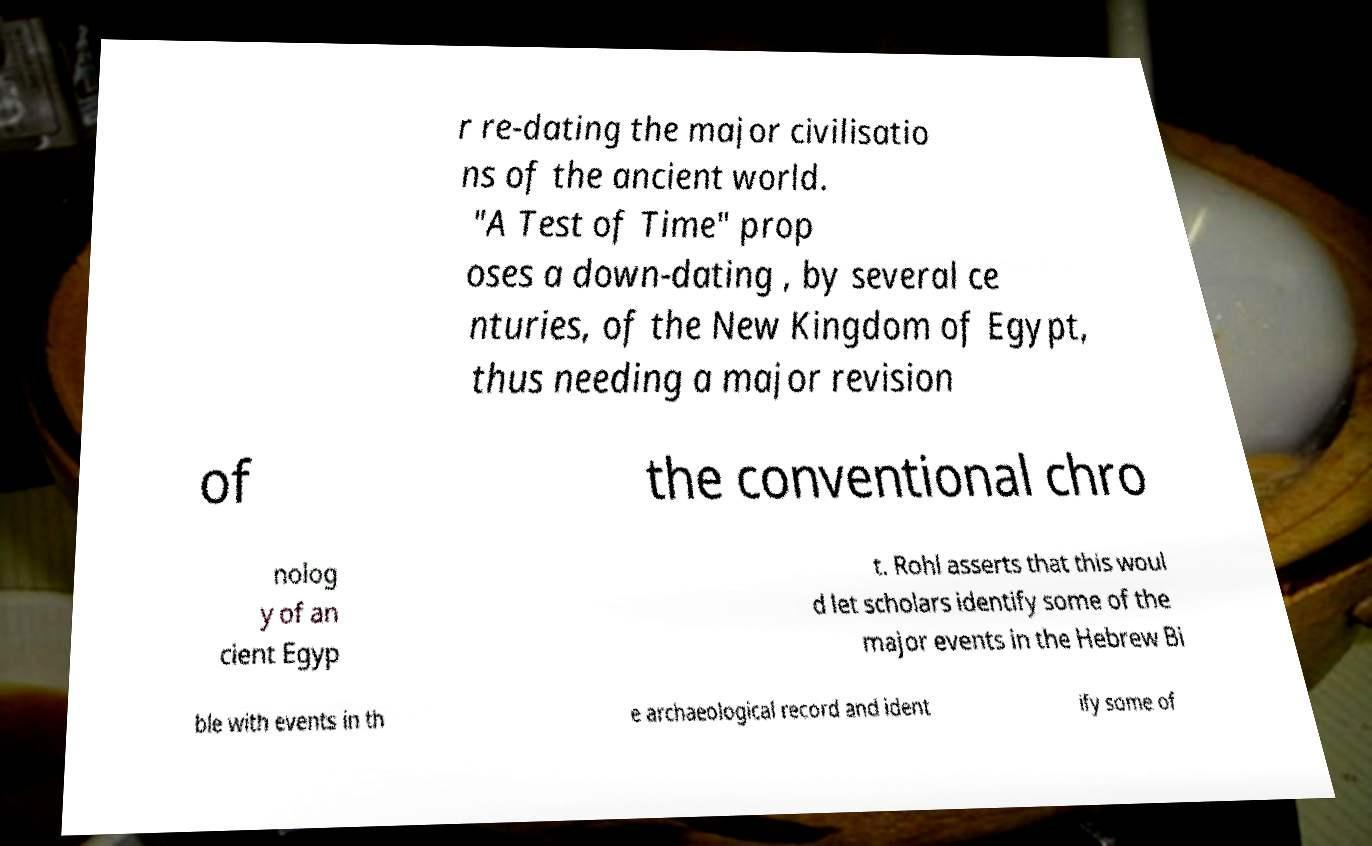Could you extract and type out the text from this image? r re-dating the major civilisatio ns of the ancient world. "A Test of Time" prop oses a down-dating , by several ce nturies, of the New Kingdom of Egypt, thus needing a major revision of the conventional chro nolog y of an cient Egyp t. Rohl asserts that this woul d let scholars identify some of the major events in the Hebrew Bi ble with events in th e archaeological record and ident ify some of 